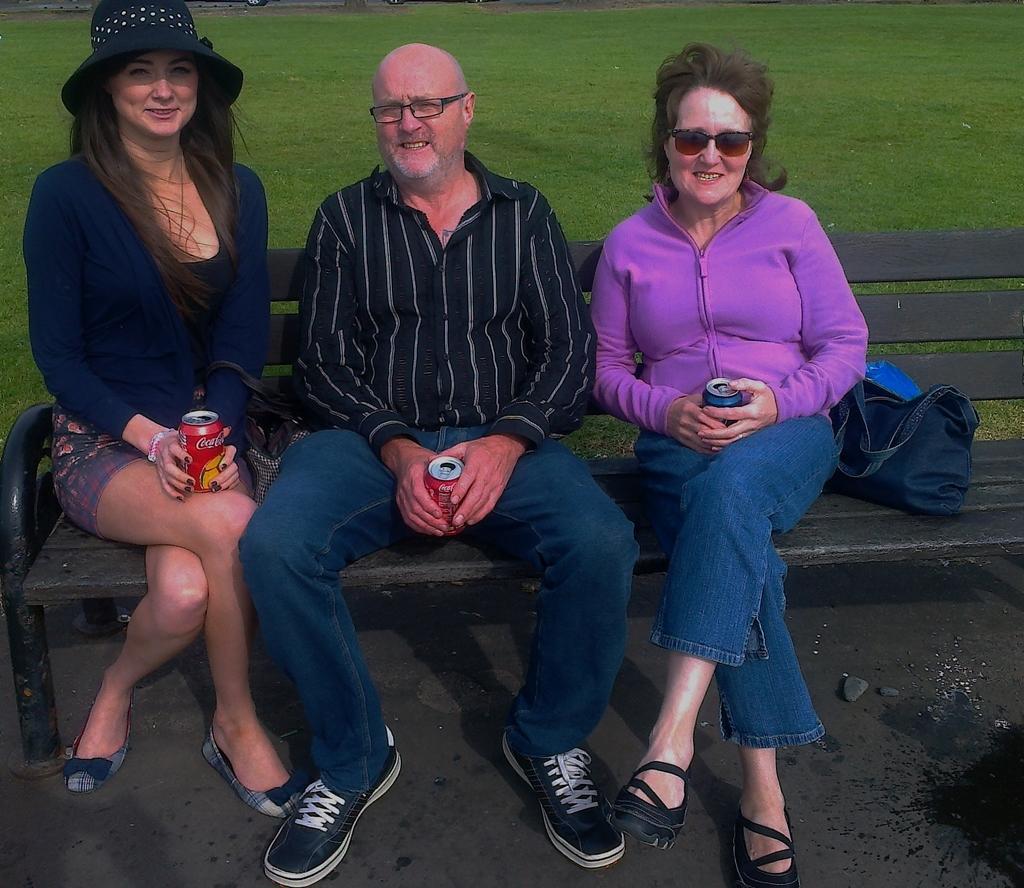Please provide a concise description of this image. In the image few people are sitting on a bench and holding tins and smiling. Behind them there's grass, on the bench there's a bag. 